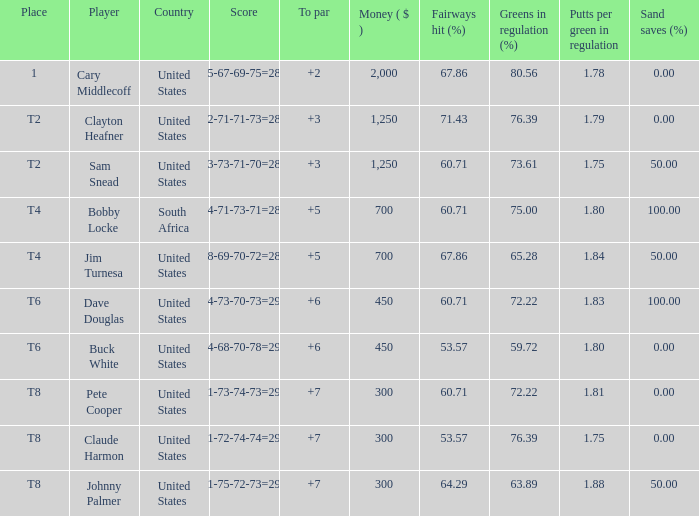What Country is Player Sam Snead with a To par of less than 5 from? United States. 